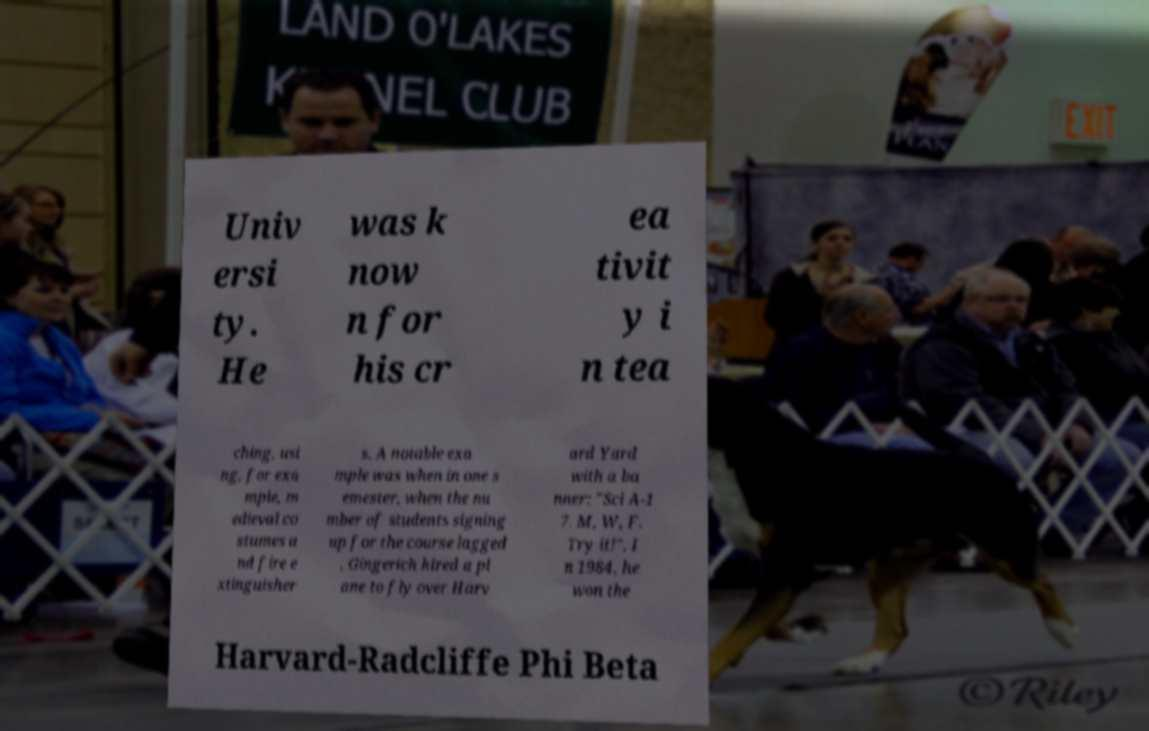Please identify and transcribe the text found in this image. Univ ersi ty. He was k now n for his cr ea tivit y i n tea ching, usi ng, for exa mple, m edieval co stumes a nd fire e xtinguisher s. A notable exa mple was when in one s emester, when the nu mber of students signing up for the course lagged , Gingerich hired a pl ane to fly over Harv ard Yard with a ba nner: "Sci A-1 7. M, W, F. Try it!". I n 1984, he won the Harvard-Radcliffe Phi Beta 